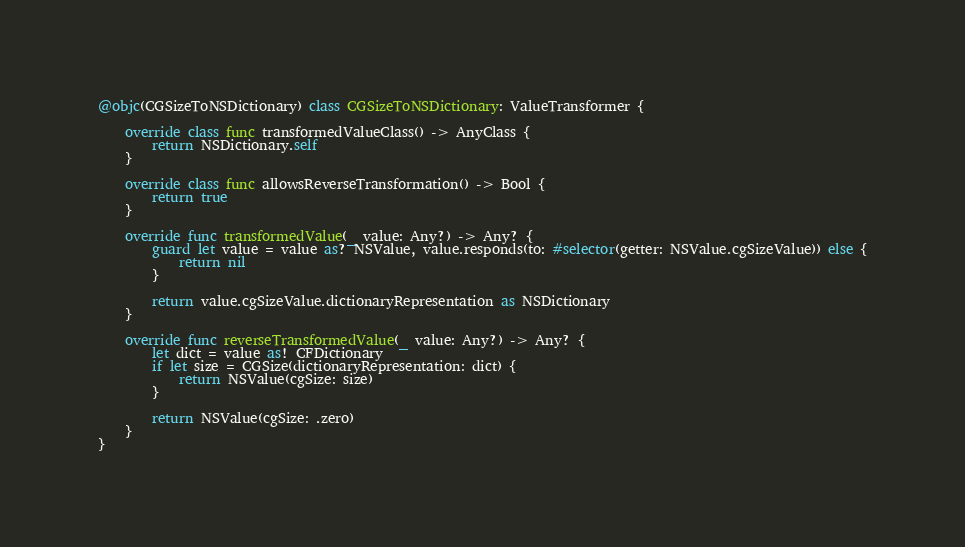Convert code to text. <code><loc_0><loc_0><loc_500><loc_500><_Swift_>@objc(CGSizeToNSDictionary) class CGSizeToNSDictionary: ValueTransformer {

    override class func transformedValueClass() -> AnyClass {
        return NSDictionary.self
    }

    override class func allowsReverseTransformation() -> Bool {
        return true
    }

    override func transformedValue(_ value: Any?) -> Any? {
        guard let value = value as? NSValue, value.responds(to: #selector(getter: NSValue.cgSizeValue)) else {
            return nil
        }

        return value.cgSizeValue.dictionaryRepresentation as NSDictionary
    }

    override func reverseTransformedValue(_ value: Any?) -> Any? {
        let dict = value as! CFDictionary
        if let size = CGSize(dictionaryRepresentation: dict) {
            return NSValue(cgSize: size)
        }

        return NSValue(cgSize: .zero)
    }
}
</code> 